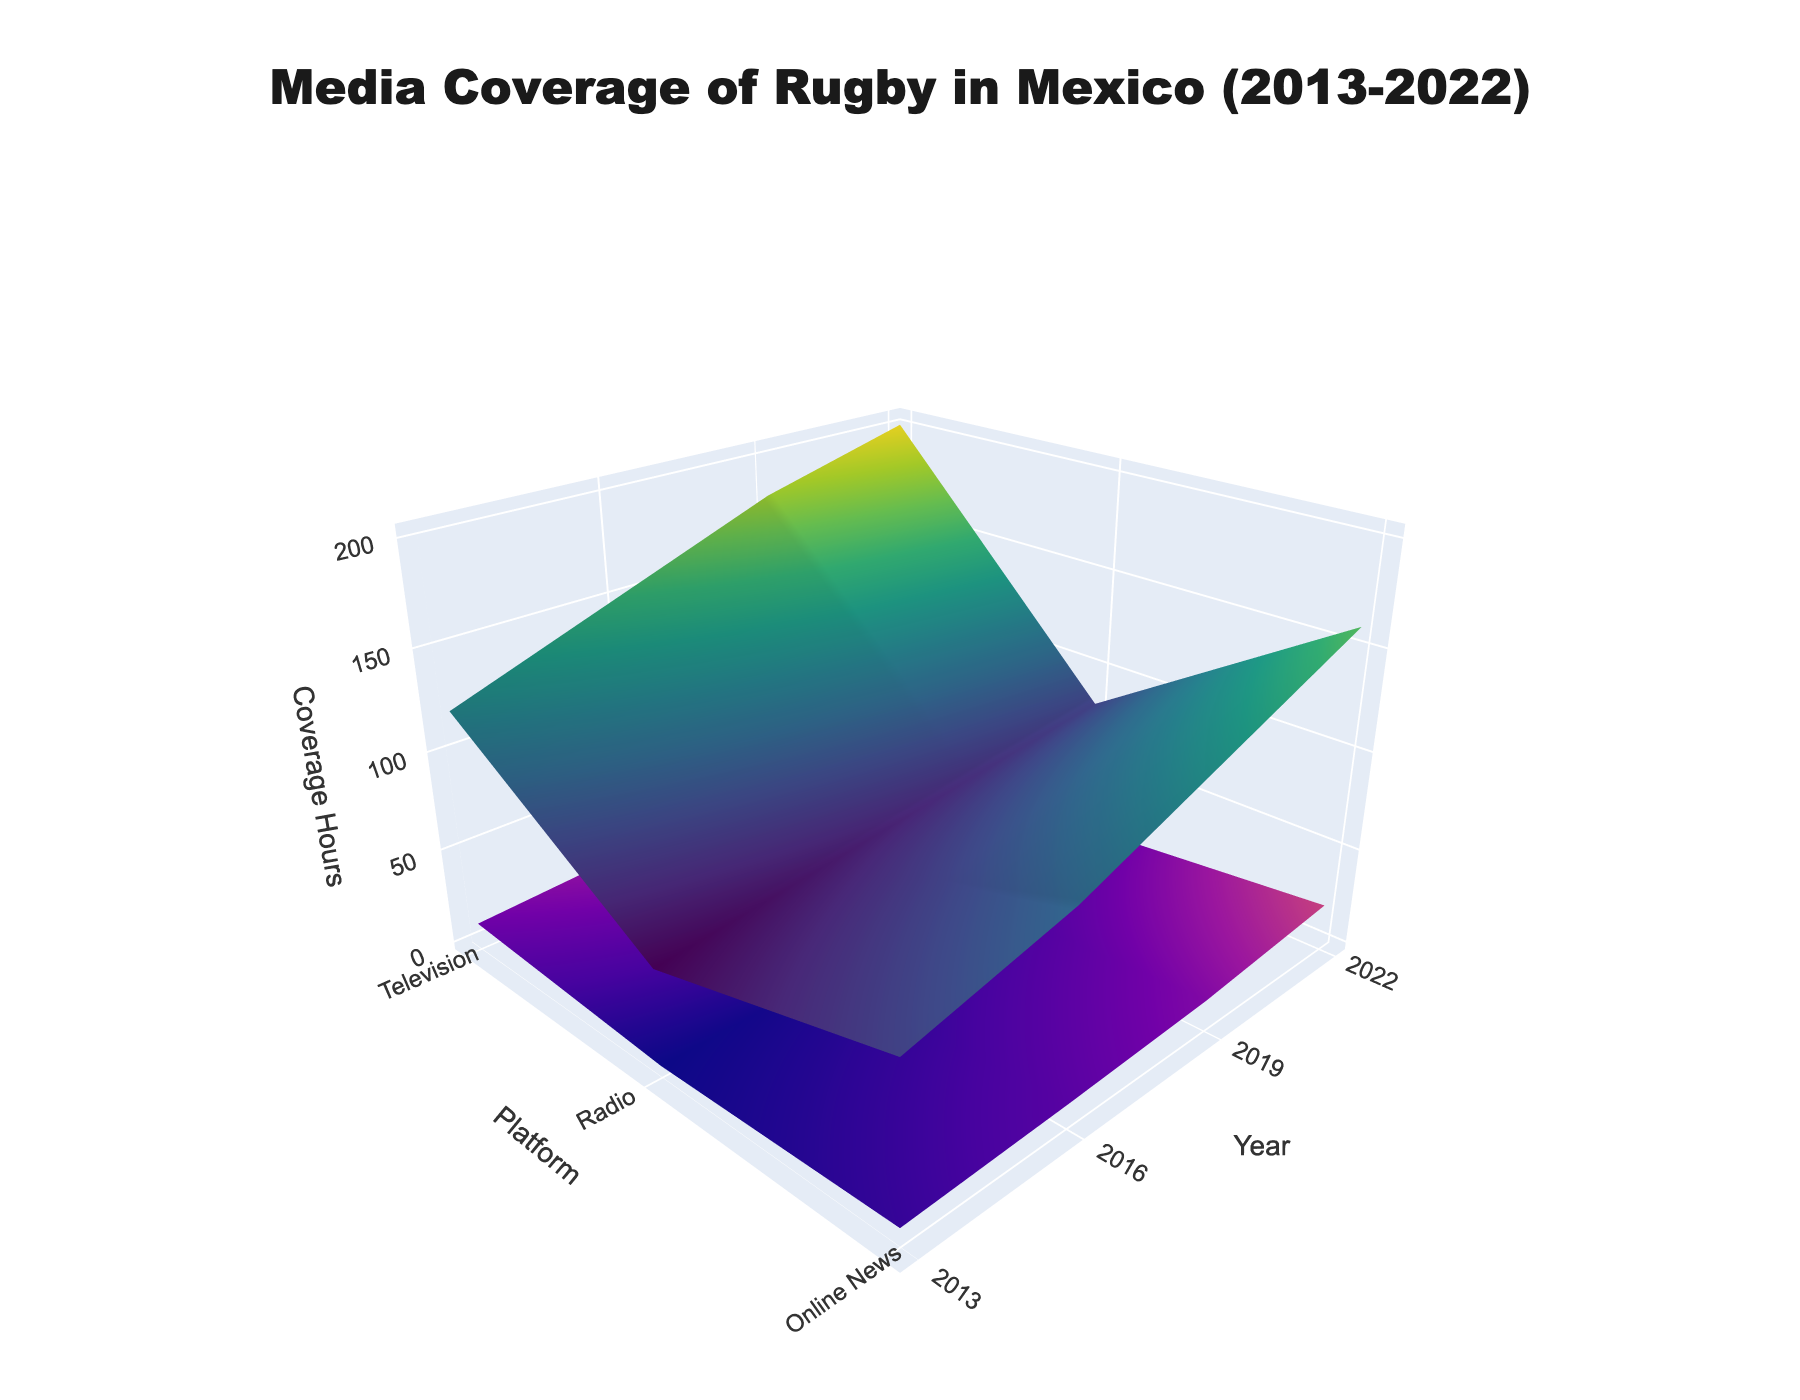What is the title of the 3D surface plot? The title is prominently displayed at the top of the chart.
Answer: Media Coverage of Rugby in Mexico (2013-2022) What are the axes labeled in the 3D surface plot? The x-axis, y-axis, and z-axis should each have a label to denote the data they represent. In this chart: x-axis is labeled 'Year', y-axis is labeled 'Platform', and z-axis is labeled 'Coverage Hours'.
Answer: Year, Platform, Coverage Hours What colors are used to represent men's and women's rugby coverage? The 3D surface plot uses two main colors to differentiate between men's and women's rugby. Men's rugby is represented by the 'Viridis' colormap, predominantly greenish, and women's rugby by the 'Plasma' colormap, predominantly purplish.
Answer: Viridis for men's rugby, Plasma for women's rugby Which platform had the highest coverage for women's rugby in 2022? Look for the highest peak in the 'Women's Rugby' surface for the year 2022 across all platforms (Television, Online News, Radio). The highest peak is observed in the Television platform.
Answer: Television How did the coverage hours for women's rugby on television change from 2013 to 2022? Examine the coverage hours for women's rugby on television in 2013 and 2022 and compare. Coverage hours increased from 10 hours in 2013 to 40 hours in 2022.
Answer: Increased from 10 to 40 hours What is the difference between men's and women's rugby coverage hours on radio in 2019? Look at the 2019 data points for radio coverage of both men's and women's rugby and calculate the difference. The values are 70 hours for men's rugby and 5 hours for women's rugby, so the difference is 70 - 5 = 65 hours.
Answer: 65 hours Which year had the most significant increase in women's rugby coverage on online news? Compare the differences year to year for women's rugby coverage on online news. The most significant increase is from 2019 to 2022, rising from 12 to 20 hours.
Answer: 2019 to 2022 Between which years did men's rugby coverage on television increase the most? Evaluate the increase in men's rugby coverage on television year by year and identify the largest jump. The significant increase is from 2019 (180 hours) to 2022 (200 hours), an increase of 20 hours.
Answer: 2019 to 2022 What were the total coverage hours across all platforms for women's rugby in 2016? Sum the coverage hours for women's rugby across all platforms (Television, Online News, Radio) for 2016. The totals are 15 (Television) + 8 (Online News) + 3 (Radio) = 26 hours.
Answer: 26 hours 